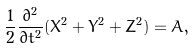<formula> <loc_0><loc_0><loc_500><loc_500>\frac { 1 } { 2 } \frac { \partial ^ { 2 } } { \partial t ^ { 2 } } ( X ^ { 2 } + Y ^ { 2 } + Z ^ { 2 } ) = A ,</formula> 